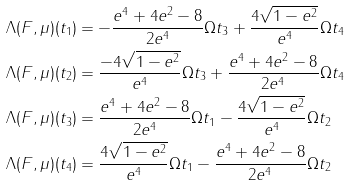<formula> <loc_0><loc_0><loc_500><loc_500>\Lambda ( F , \mu ) ( t _ { 1 } ) & = - \frac { e ^ { 4 } + 4 e ^ { 2 } - 8 } { 2 e ^ { 4 } } \Omega t _ { 3 } + \frac { 4 \sqrt { 1 - e ^ { 2 } } } { e ^ { 4 } } \Omega t _ { 4 } \\ \Lambda ( F , \mu ) ( t _ { 2 } ) & = \frac { - 4 \sqrt { 1 - e ^ { 2 } } } { e ^ { 4 } } \Omega t _ { 3 } + \frac { e ^ { 4 } + 4 e ^ { 2 } - 8 } { 2 e ^ { 4 } } \Omega t _ { 4 } \\ \Lambda ( F , \mu ) ( t _ { 3 } ) & = \frac { e ^ { 4 } + 4 e ^ { 2 } - 8 } { 2 e ^ { 4 } } \Omega t _ { 1 } - \frac { 4 \sqrt { 1 - e ^ { 2 } } } { e ^ { 4 } } \Omega t _ { 2 } \\ \Lambda ( F , \mu ) ( t _ { 4 } ) & = \frac { 4 \sqrt { 1 - e ^ { 2 } } } { e ^ { 4 } } \Omega t _ { 1 } - \frac { e ^ { 4 } + 4 e ^ { 2 } - 8 } { 2 e ^ { 4 } } \Omega t _ { 2 }</formula> 